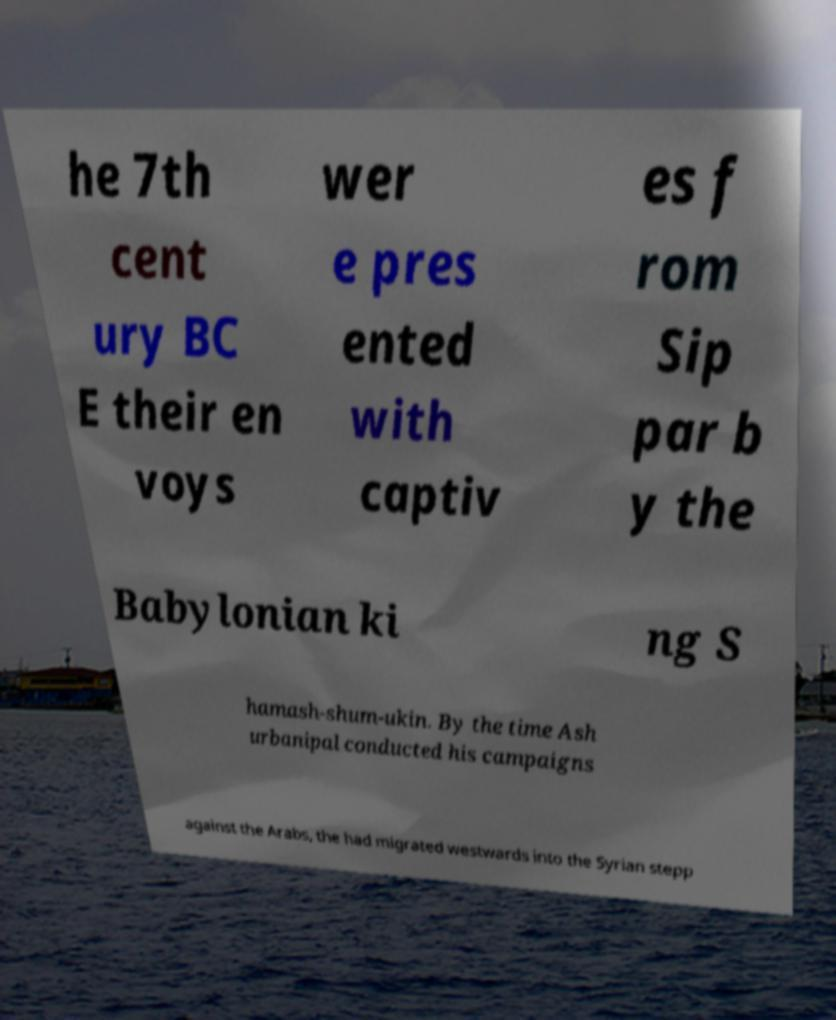For documentation purposes, I need the text within this image transcribed. Could you provide that? he 7th cent ury BC E their en voys wer e pres ented with captiv es f rom Sip par b y the Babylonian ki ng S hamash-shum-ukin. By the time Ash urbanipal conducted his campaigns against the Arabs, the had migrated westwards into the Syrian stepp 